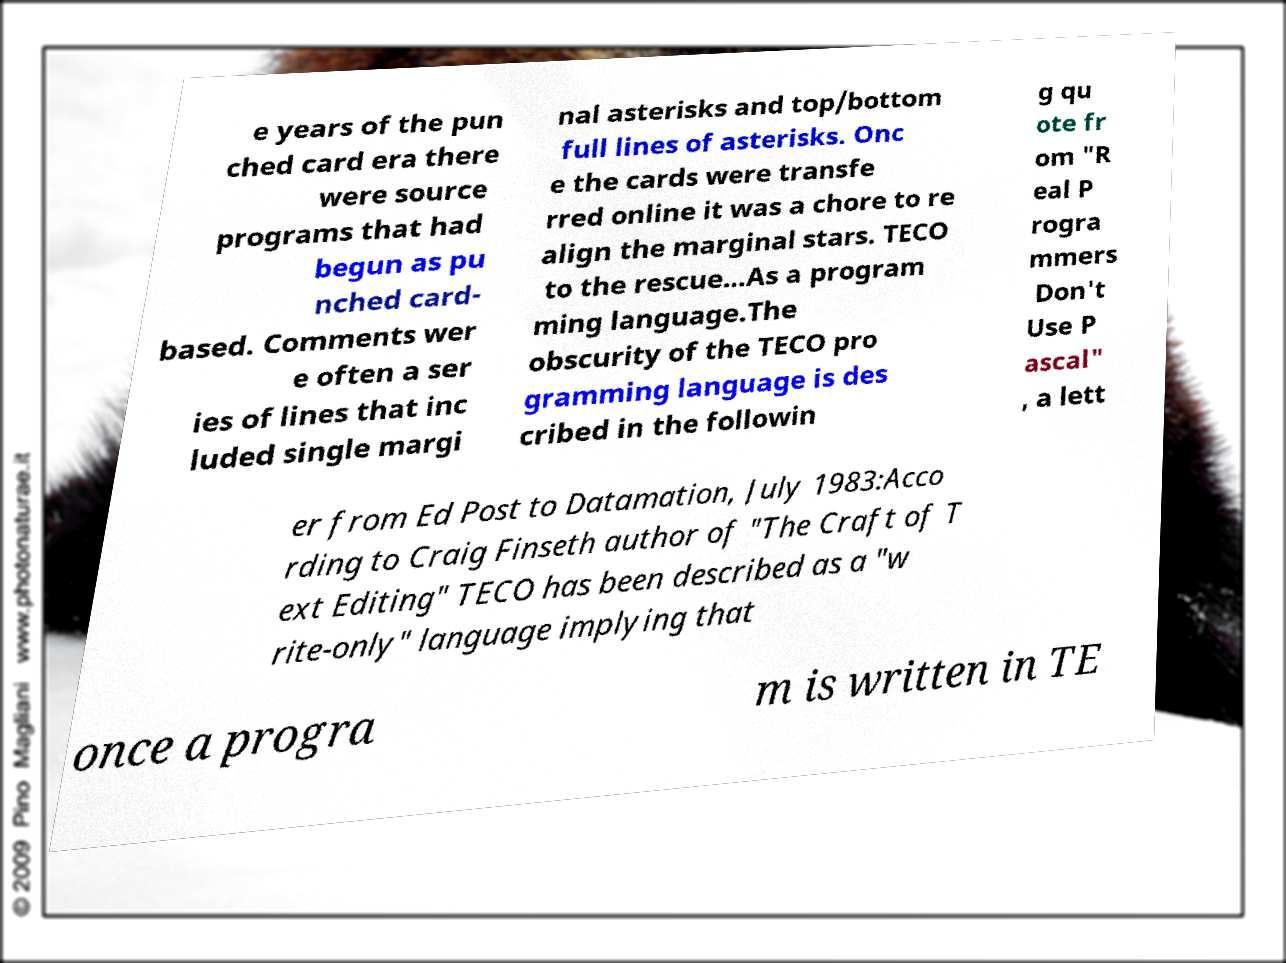Please identify and transcribe the text found in this image. e years of the pun ched card era there were source programs that had begun as pu nched card- based. Comments wer e often a ser ies of lines that inc luded single margi nal asterisks and top/bottom full lines of asterisks. Onc e the cards were transfe rred online it was a chore to re align the marginal stars. TECO to the rescue...As a program ming language.The obscurity of the TECO pro gramming language is des cribed in the followin g qu ote fr om "R eal P rogra mmers Don't Use P ascal" , a lett er from Ed Post to Datamation, July 1983:Acco rding to Craig Finseth author of "The Craft of T ext Editing" TECO has been described as a "w rite-only" language implying that once a progra m is written in TE 